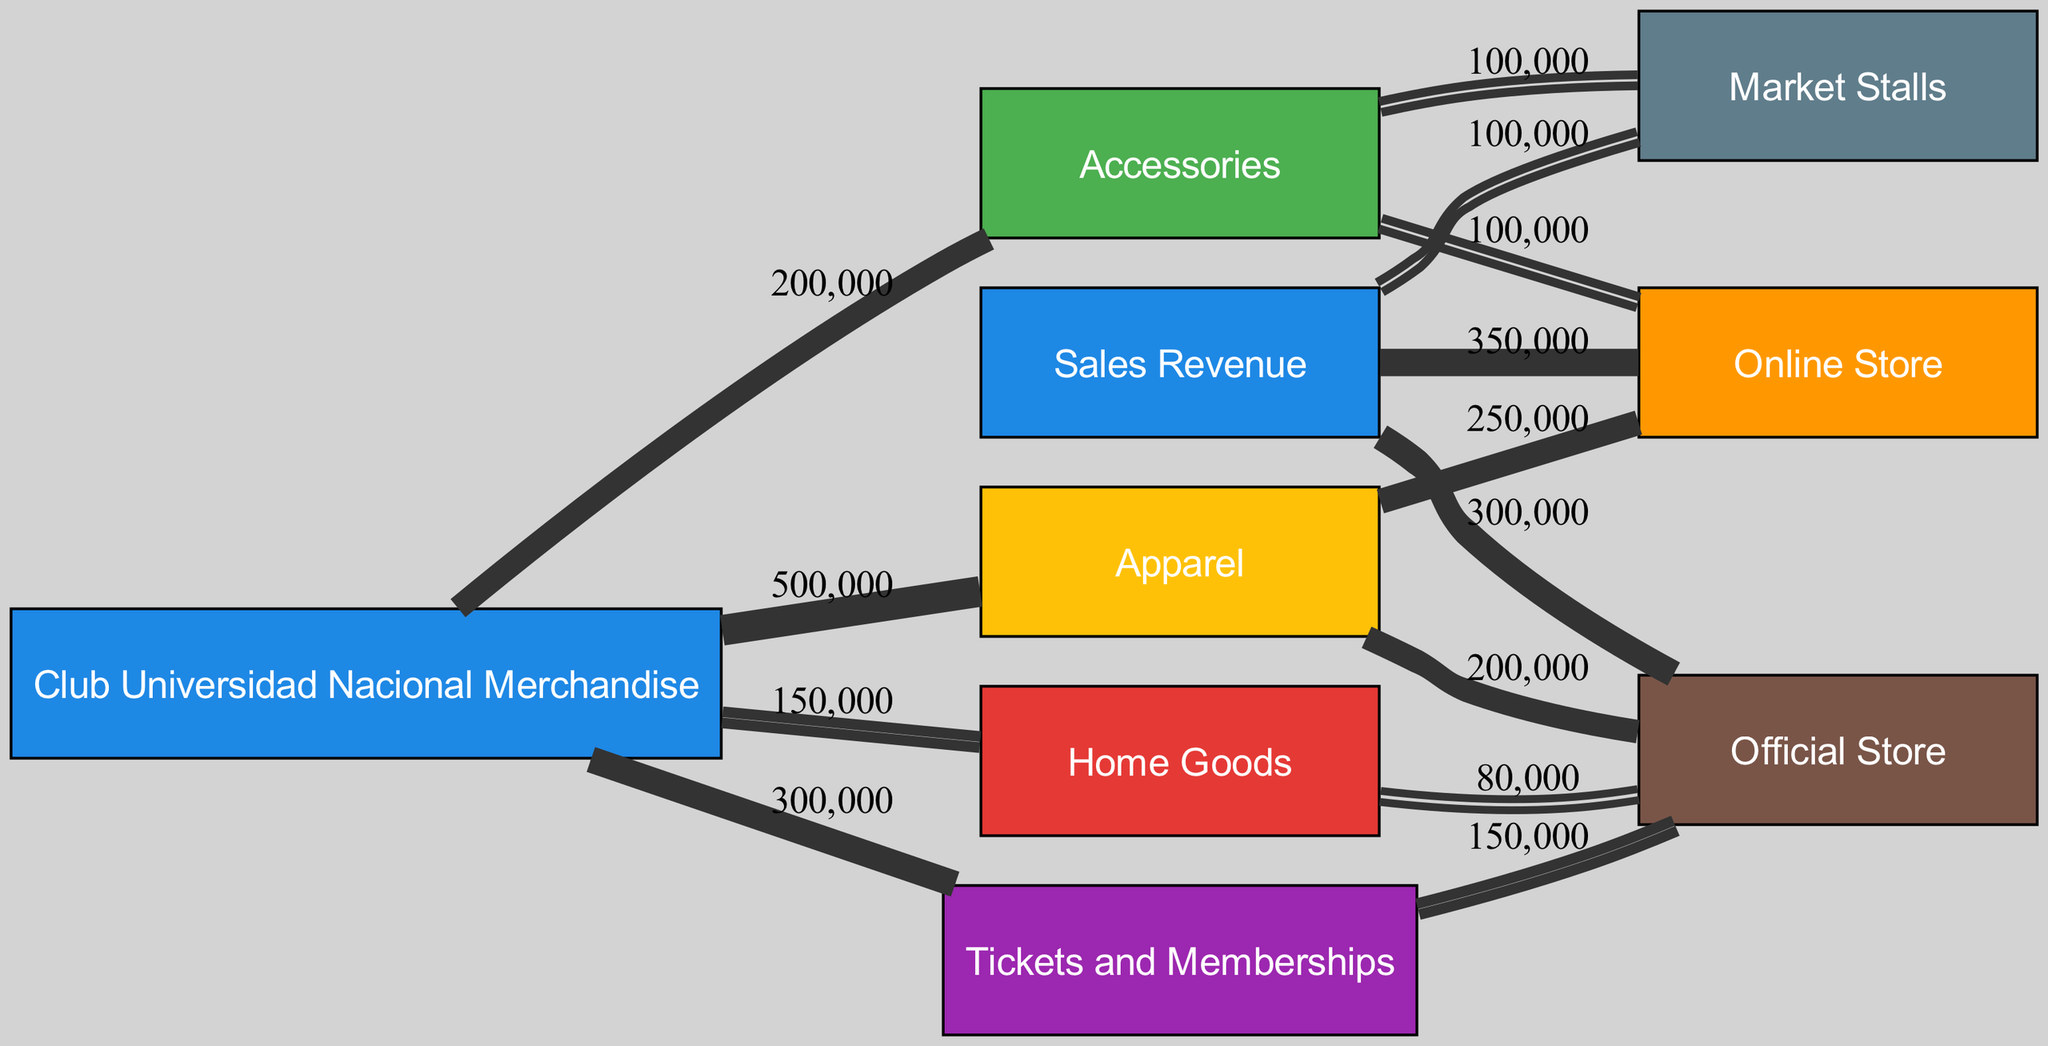What is the total sales revenue from merchandise? The diagram shows that the total sales revenue is represented by the node "Sales Revenue," which connects to various categories of sales. The value directly linked to this node indicates the total amount, which is $1,000,000 obtained by summing all linked values.
Answer: 1,000,000 Which category has the highest sales amount? In the diagram, the category "Apparel" has the largest outgoing link to the "Club Universidad Nacional Merchandise" node with a sales value of $500,000, making it the category with the highest sales amount.
Answer: Apparel How much revenue does the Official Store generate from "Tickets and Memberships"? The link between "Tickets and Memberships" and "Official Store" shows a value of $150,000, indicating this specific revenue flow from that category to the store.
Answer: 150,000 What is the total revenue coming from Online Sales? By adding the values from the links connecting to "Online Store"—$250,000 from "Apparel" and $100,000 from "Accessories"—the total revenue from online sales can be calculated as $350,000.
Answer: 350,000 Which revenue flow generates the least amount of revenue? The link from "Sales Revenue" to "Market Stalls" shows a value of $100,000, which is the lowest among the outgoing flows from the "Sales Revenue" node, indicating it generates the least revenue.
Answer: Market Stalls How many categories are directly connected to the total sales revenue? The total sales revenue node connects directly to four categories: "Apparel," "Accessories," "Home Goods," and "Tickets and Memberships." Therefore, the count of these categories is four.
Answer: 4 What percentage of total sales comes from Apparel? The value of "Apparel" is $500,000, and the total sales revenue is $1,000,000. Calculating the percentage gives (500,000/1,000,000) * 100% = 50%, indicating that 50% of the total sales come from "Apparel."
Answer: 50% Which revenue flow has the same value as Accessories from the Online Store? The flow from "Accessories" to "Market Stalls" also has a value of $100,000, which is equal to the $100,000 coming from the "Accessories" to "Online Store." The value of $100,000 matches.
Answer: 100,000 